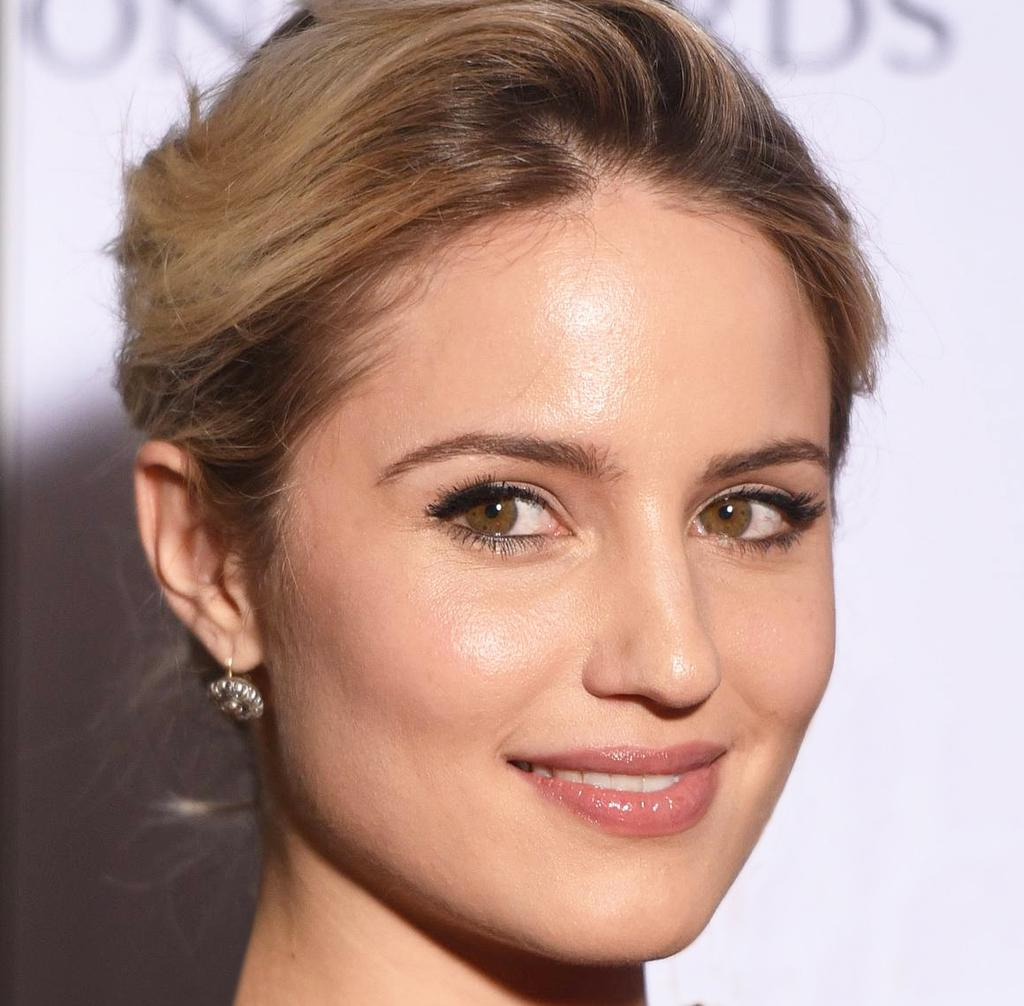What is the main subject of the image? There is a person's face in the image. What color is the background of the image? The background of the image is white. What else can be seen in the image besides the person's face? There is text in the image. Can you hear the bell ringing in the image? There is no bell present in the image, so it cannot be heard. What type of debt is being discussed in the image? There is no mention of debt in the image. 